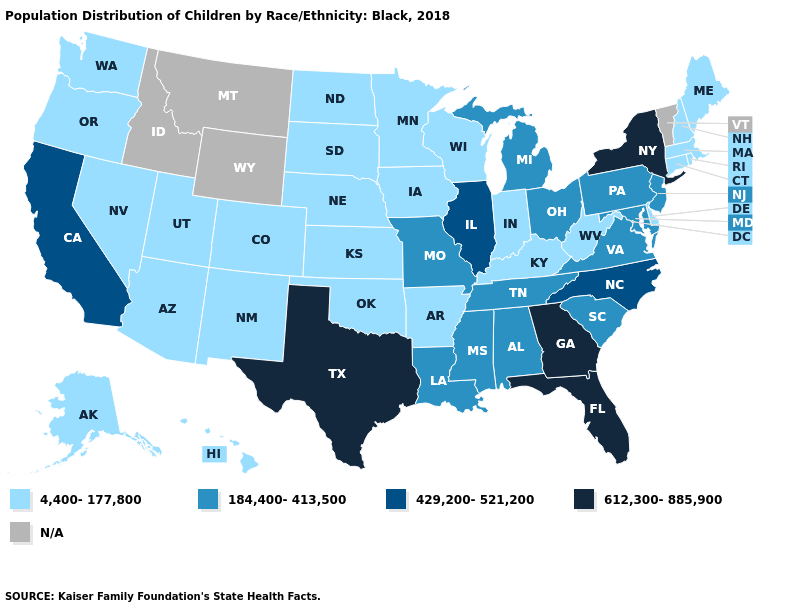What is the value of Oklahoma?
Answer briefly. 4,400-177,800. Which states have the lowest value in the USA?
Keep it brief. Alaska, Arizona, Arkansas, Colorado, Connecticut, Delaware, Hawaii, Indiana, Iowa, Kansas, Kentucky, Maine, Massachusetts, Minnesota, Nebraska, Nevada, New Hampshire, New Mexico, North Dakota, Oklahoma, Oregon, Rhode Island, South Dakota, Utah, Washington, West Virginia, Wisconsin. Is the legend a continuous bar?
Concise answer only. No. What is the highest value in the South ?
Answer briefly. 612,300-885,900. What is the value of Maryland?
Concise answer only. 184,400-413,500. Name the states that have a value in the range N/A?
Give a very brief answer. Idaho, Montana, Vermont, Wyoming. What is the highest value in the South ?
Answer briefly. 612,300-885,900. What is the lowest value in states that border Massachusetts?
Give a very brief answer. 4,400-177,800. Does Alaska have the lowest value in the USA?
Write a very short answer. Yes. Among the states that border North Dakota , which have the lowest value?
Short answer required. Minnesota, South Dakota. Which states have the lowest value in the USA?
Quick response, please. Alaska, Arizona, Arkansas, Colorado, Connecticut, Delaware, Hawaii, Indiana, Iowa, Kansas, Kentucky, Maine, Massachusetts, Minnesota, Nebraska, Nevada, New Hampshire, New Mexico, North Dakota, Oklahoma, Oregon, Rhode Island, South Dakota, Utah, Washington, West Virginia, Wisconsin. Name the states that have a value in the range 184,400-413,500?
Answer briefly. Alabama, Louisiana, Maryland, Michigan, Mississippi, Missouri, New Jersey, Ohio, Pennsylvania, South Carolina, Tennessee, Virginia. Does Florida have the highest value in the USA?
Keep it brief. Yes. Which states have the lowest value in the USA?
Short answer required. Alaska, Arizona, Arkansas, Colorado, Connecticut, Delaware, Hawaii, Indiana, Iowa, Kansas, Kentucky, Maine, Massachusetts, Minnesota, Nebraska, Nevada, New Hampshire, New Mexico, North Dakota, Oklahoma, Oregon, Rhode Island, South Dakota, Utah, Washington, West Virginia, Wisconsin. 